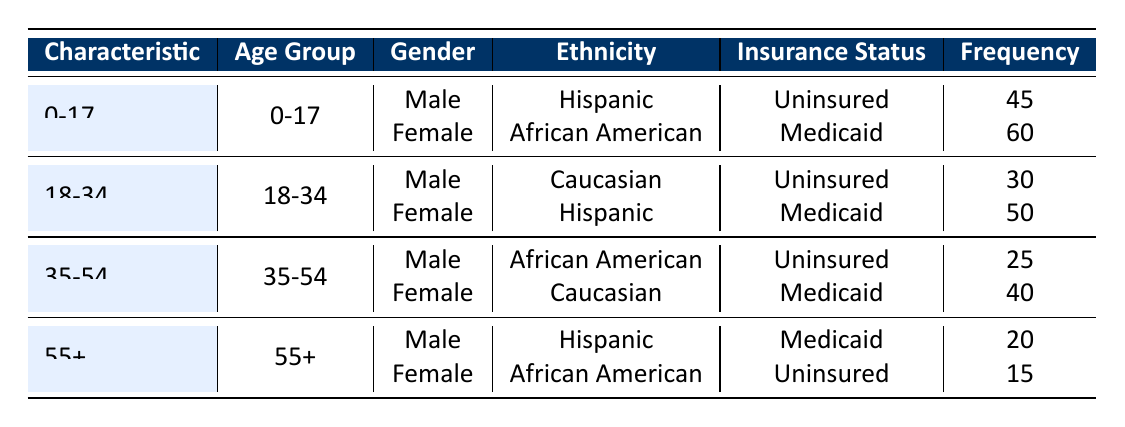What is the frequency of uninsured males aged 0-17? From the table, we can locate males in the 0-17 age group. The corresponding frequency for uninsured males aged 0-17 is 45.
Answer: 45 How many females aged 35-54 are on Medicaid? Looking at the 35-54 age group, we find the data for females. The table shows that females in this group on Medicaid have a frequency of 40.
Answer: 40 What is the total frequency of patients aged 55 and older? To find the total frequency for patients aged 55+, we will sum the frequencies of both males (20) and females (15) in that age group: 20 + 15 = 35.
Answer: 35 Are there more males or females in the 18-34 age group that are uninsured? In the 18-34 age group, males are uninsured with a frequency of 30, while females are on Medicaid with a frequency of 50. This means there are more females but none are uninsured. So, the answer is that there are more females than males that are uninsured.
Answer: No, there are not more males What is the total frequency of uninsured patients across all age groups? From the table, noted for each group: males aged 0-17 (45), males aged 18-34 (30), and males aged 35-54 (25) provide the frequencies of uninsured patients. Summing these frequencies: 45 + 30 + 25 + 15 (females aged 55+) = 115 gives a total frequency of 115 for uninsured patients.
Answer: 115 Which ethnic group has the highest frequency among uninsured patients in the table? Analyzing the ethnicities under uninsured status, the frequencies are: Hispanic males aged 0-17 (45), Caucasian males aged 18-34 (30), and African American males aged 35-54 (25). Here, Hispanic males aged 0-17 (45) has the highest frequency among uninsured groups.
Answer: Hispanic What is the frequency of Medicaid patients who are African American females? Referring to the 0-17 and 35-54 age groups, the only African American females identified are in the 0-17 group (60, Medicaid) and in the 55+ category (15, uninsured). The relevant frequency we need is 15 for Medicaid African American females aged 35-54.
Answer: 15 How many total females vs. total males are seeking healthcare services? Summing females across all groups: (60 + 50 + 40 + 15) = 165. Summing males: (45 + 30 + 25 + 20) = 120. Thus, females exceed males, leading us to see that female patients outnumber males (165 vs 120).
Answer: 165 females; 120 males What is the frequency of uninsured patients in the 35-54 age group? The frequencies of uninsured patients in the 35-54 age group yield: males (25) and females are consequently uninsured at a frequency of 15. Summing them yields a total uninsured patient frequency of 40.
Answer: 40 